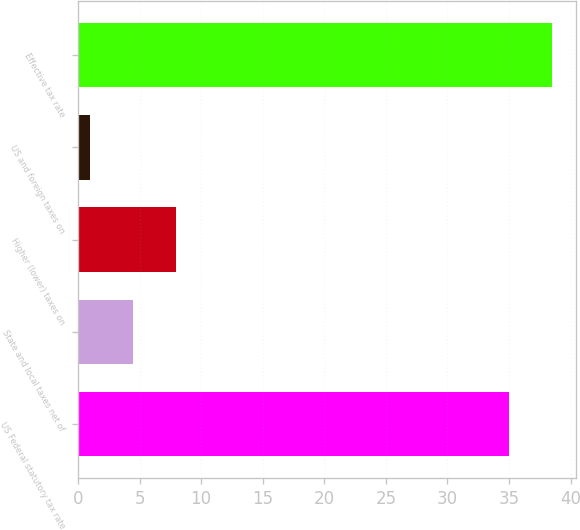Convert chart. <chart><loc_0><loc_0><loc_500><loc_500><bar_chart><fcel>US Federal statutory tax rate<fcel>State and local taxes net of<fcel>Higher (lower) taxes on<fcel>US and foreign taxes on<fcel>Effective tax rate<nl><fcel>35<fcel>4.5<fcel>8<fcel>1<fcel>38.5<nl></chart> 